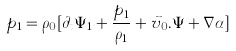<formula> <loc_0><loc_0><loc_500><loc_500>p _ { 1 } = { \rho } _ { 0 } [ { \partial } _ { t } { \Psi } _ { 1 } + \frac { p _ { 1 } } { { \rho } _ { 1 } } + \vec { v } _ { 0 } . { \Psi } + { \nabla } { \alpha } ]</formula> 